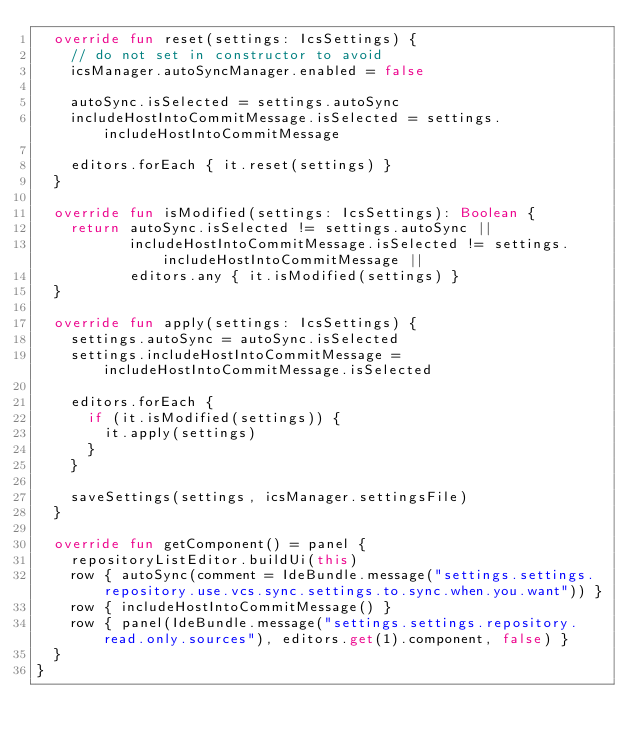Convert code to text. <code><loc_0><loc_0><loc_500><loc_500><_Kotlin_>  override fun reset(settings: IcsSettings) {
    // do not set in constructor to avoid
    icsManager.autoSyncManager.enabled = false

    autoSync.isSelected = settings.autoSync
    includeHostIntoCommitMessage.isSelected = settings.includeHostIntoCommitMessage

    editors.forEach { it.reset(settings) }
  }

  override fun isModified(settings: IcsSettings): Boolean {
    return autoSync.isSelected != settings.autoSync ||
           includeHostIntoCommitMessage.isSelected != settings.includeHostIntoCommitMessage ||
           editors.any { it.isModified(settings) }
  }

  override fun apply(settings: IcsSettings) {
    settings.autoSync = autoSync.isSelected
    settings.includeHostIntoCommitMessage = includeHostIntoCommitMessage.isSelected

    editors.forEach {
      if (it.isModified(settings)) {
        it.apply(settings)
      }
    }

    saveSettings(settings, icsManager.settingsFile)
  }

  override fun getComponent() = panel {
    repositoryListEditor.buildUi(this)
    row { autoSync(comment = IdeBundle.message("settings.settings.repository.use.vcs.sync.settings.to.sync.when.you.want")) }
    row { includeHostIntoCommitMessage() }
    row { panel(IdeBundle.message("settings.settings.repository.read.only.sources"), editors.get(1).component, false) }
  }
}</code> 